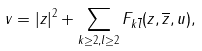Convert formula to latex. <formula><loc_0><loc_0><loc_500><loc_500>v = | z | ^ { 2 } + \sum _ { k \geq 2 , l \geq 2 } F _ { k \overline { l } } ( z , \overline { z } , u ) ,</formula> 